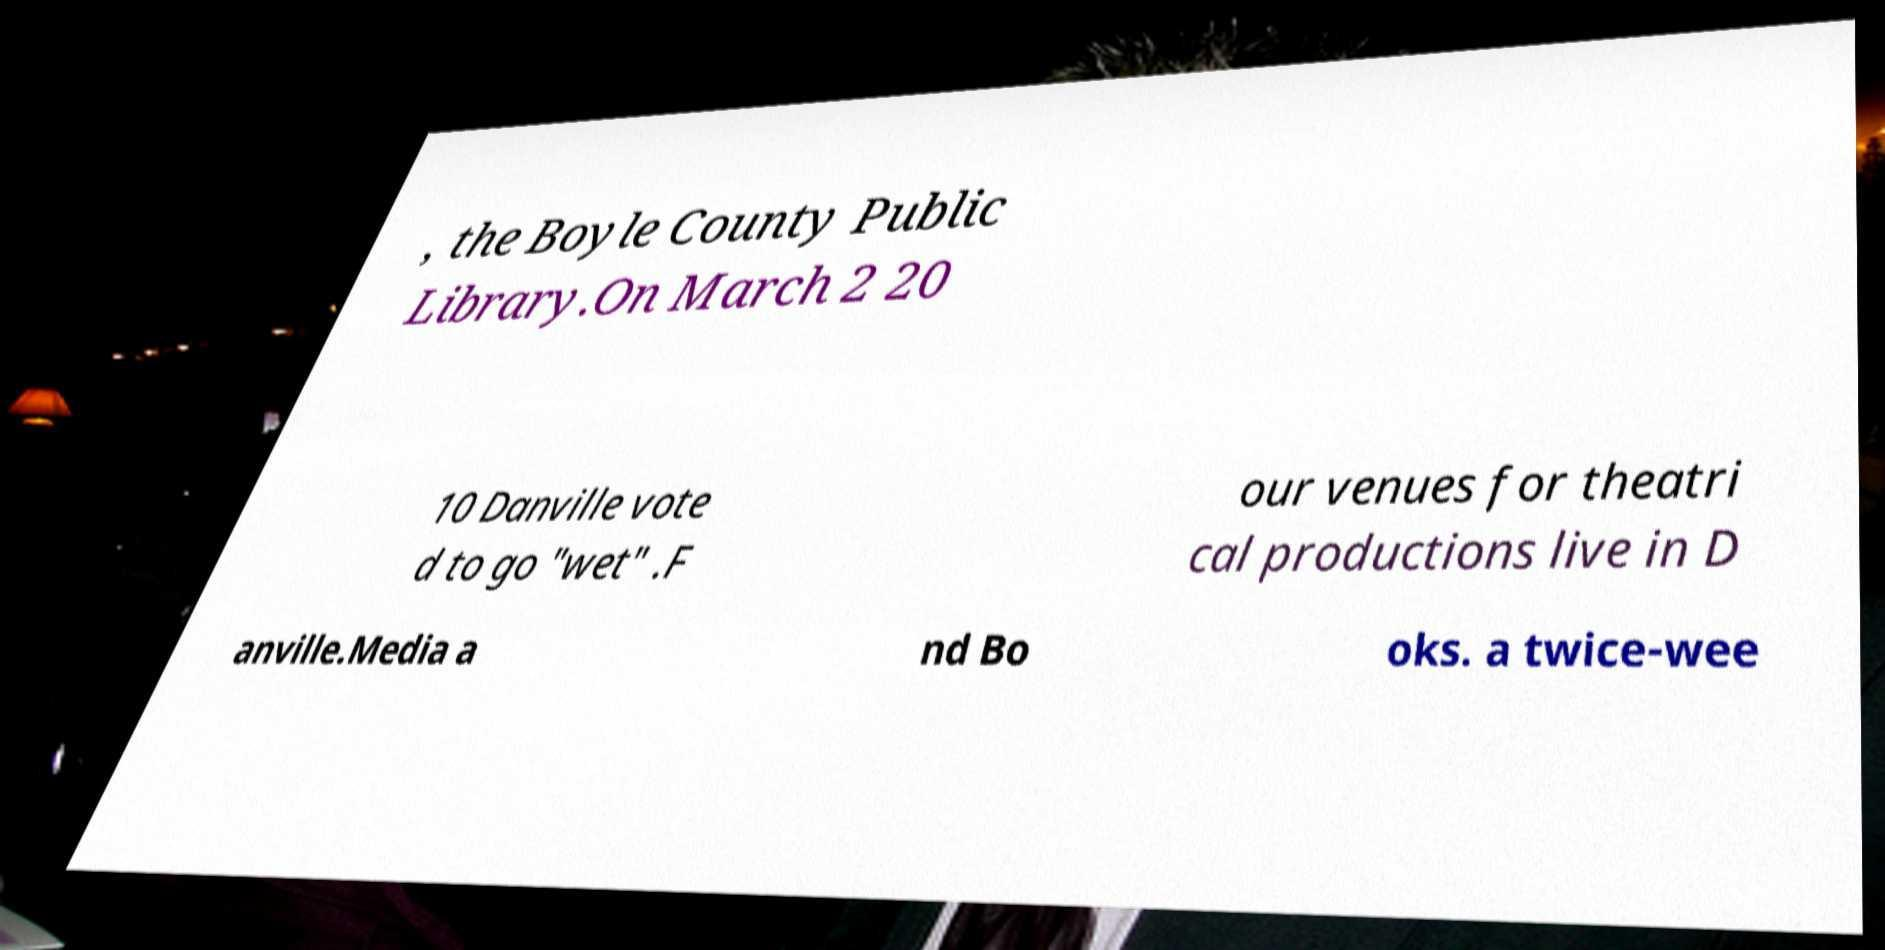I need the written content from this picture converted into text. Can you do that? , the Boyle County Public Library.On March 2 20 10 Danville vote d to go "wet" .F our venues for theatri cal productions live in D anville.Media a nd Bo oks. a twice-wee 